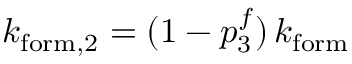<formula> <loc_0><loc_0><loc_500><loc_500>k _ { f o r m , 2 } = ( 1 - p _ { 3 } ^ { f } ) \, k _ { f o r m }</formula> 